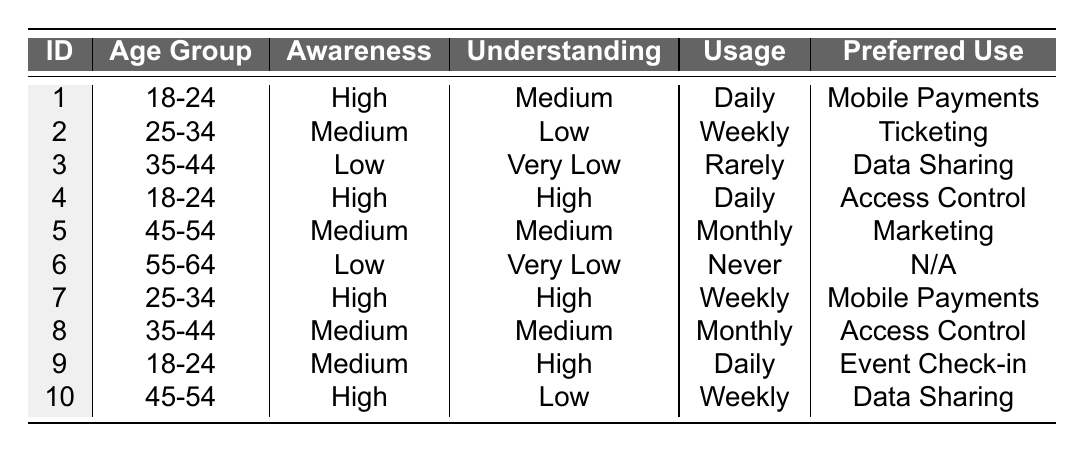What is the preferred use case for the respondent with the highest awareness level? The respondent with the highest awareness level is either ID 1 or ID 4. ID 1 prefers "Mobile Payments," and ID 4 prefers "Access Control." Therefore, both use cases are valid; however, ID 1 is the first respondent listed.
Answer: Mobile Payments How many respondents report a low understanding level? We need to look for respondents who have a "Low" understanding level listed in the table. IDs 2, 3, and 10 are the only ones who fall into this category, which totals to 3 respondents.
Answer: 3 What percentage of respondents use NFC technology daily? There are 10 respondents in total. By checking the usage frequency, IDs 1, 4, and 9 are reported to use it daily, which gives us 3 daily users. To find the percentage, calculate (3/10) * 100 = 30%.
Answer: 30% Which age group has the most respondents reporting high awareness? We can find the high awareness respondents in each age group. The 18-24 age group has 2 respondents (IDs 1 and 4) reporting high awareness, while the 25-34 age group has 2 (IDs 7) as well, and there are no respondents in the 35-44 and 45-54 groups with high awareness. So, both age groups tie.
Answer: 18-24 and 25-34 What is the average understanding level among respondents in the age group 45-54? There are 2 respondents in this age group (IDs 5 and 10). Their understanding levels are Medium and Low. Assigning numerical values (Medium=2, Low=1), we have (2 + 1)/2 = 1.5. This translates back to an average understanding level of Medium-Low between the two.
Answer: Medium-Low Is there a respondent who never uses NFC but has high awareness? Looking through the table, ID 6 has "Never" usage frequency and "Low" awareness. No respondents fit the criteria of having high awareness along with never using NFC.
Answer: No For the preferred use case "Data Sharing," how many respondents have a medium level of awareness? The usage of "Data Sharing" refers to IDs 3 and 10. ID 3 has Low awareness, while ID 10 reports High awareness. Hence, there are no respondents reporting Data Sharing with medium awareness.
Answer: 0 How many respondents are in the age group 35-44 and report medium understanding? There are two respondents in the age group 35-44: ID 3 (Low understanding) and ID 8 (Medium understanding). Thus, only ID 8 fits the criteria for medium understanding.
Answer: 1 What is the preferred use case for the respondent with the lowest understanding level? The lowest understanding level is "Very Low," which applies to IDs 3 and 6. ID 3 prefers "Data Sharing," while ID 6 is marked as "Not Applicable." The preferred use case for the lowest understanding level is "Not Applicable."
Answer: Not Applicable Which age group has respondents that report a high understanding level? The age groups with a high understanding level are those reported in IDs 4 and 7, both age groups 18-24 and 25-34 have respondents with high understanding.
Answer: 18-24 and 25-34 